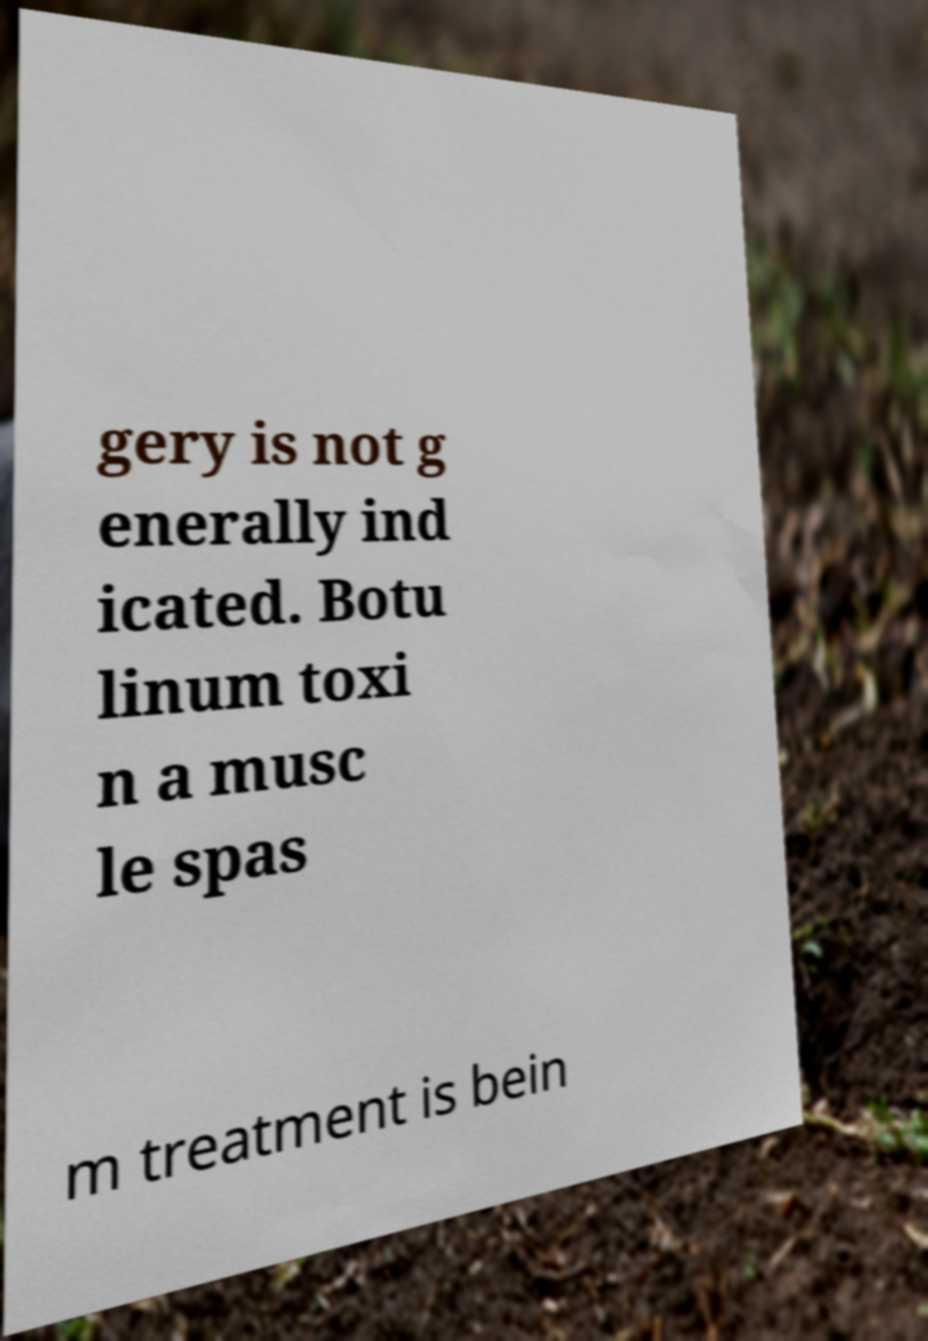I need the written content from this picture converted into text. Can you do that? gery is not g enerally ind icated. Botu linum toxi n a musc le spas m treatment is bein 